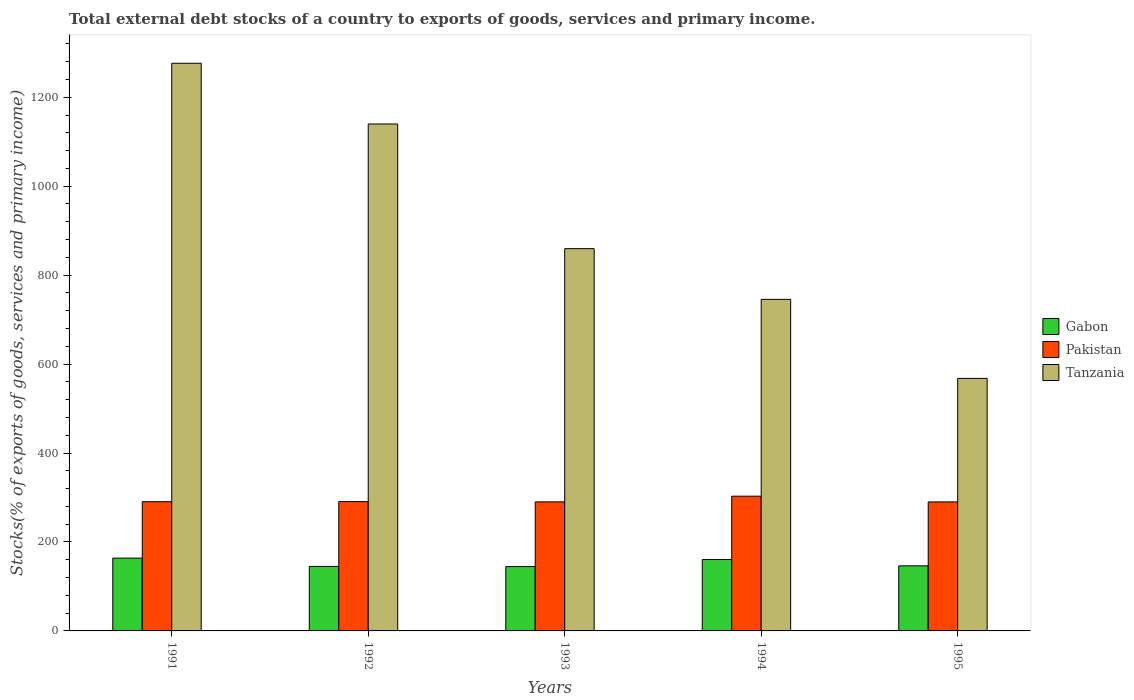How many different coloured bars are there?
Give a very brief answer. 3. Are the number of bars on each tick of the X-axis equal?
Offer a terse response. Yes. How many bars are there on the 4th tick from the left?
Offer a terse response. 3. What is the label of the 1st group of bars from the left?
Give a very brief answer. 1991. In how many cases, is the number of bars for a given year not equal to the number of legend labels?
Your answer should be very brief. 0. What is the total debt stocks in Pakistan in 1994?
Your response must be concise. 302.96. Across all years, what is the maximum total debt stocks in Gabon?
Your answer should be very brief. 163.68. Across all years, what is the minimum total debt stocks in Tanzania?
Keep it short and to the point. 567.82. In which year was the total debt stocks in Tanzania maximum?
Make the answer very short. 1991. What is the total total debt stocks in Pakistan in the graph?
Make the answer very short. 1464.63. What is the difference between the total debt stocks in Tanzania in 1992 and that in 1994?
Offer a very short reply. 394.38. What is the difference between the total debt stocks in Gabon in 1993 and the total debt stocks in Tanzania in 1991?
Keep it short and to the point. -1131.76. What is the average total debt stocks in Pakistan per year?
Offer a terse response. 292.93. In the year 1993, what is the difference between the total debt stocks in Tanzania and total debt stocks in Pakistan?
Give a very brief answer. 569.36. In how many years, is the total debt stocks in Gabon greater than 1280 %?
Ensure brevity in your answer.  0. What is the ratio of the total debt stocks in Gabon in 1991 to that in 1994?
Ensure brevity in your answer.  1.02. Is the difference between the total debt stocks in Tanzania in 1991 and 1994 greater than the difference between the total debt stocks in Pakistan in 1991 and 1994?
Keep it short and to the point. Yes. What is the difference between the highest and the second highest total debt stocks in Gabon?
Provide a succinct answer. 3.03. What is the difference between the highest and the lowest total debt stocks in Gabon?
Make the answer very short. 19.03. In how many years, is the total debt stocks in Pakistan greater than the average total debt stocks in Pakistan taken over all years?
Provide a short and direct response. 1. Is the sum of the total debt stocks in Gabon in 1993 and 1995 greater than the maximum total debt stocks in Pakistan across all years?
Keep it short and to the point. No. What does the 3rd bar from the left in 1994 represents?
Provide a succinct answer. Tanzania. Are all the bars in the graph horizontal?
Make the answer very short. No. Are the values on the major ticks of Y-axis written in scientific E-notation?
Keep it short and to the point. No. Where does the legend appear in the graph?
Offer a terse response. Center right. How are the legend labels stacked?
Keep it short and to the point. Vertical. What is the title of the graph?
Provide a short and direct response. Total external debt stocks of a country to exports of goods, services and primary income. Does "Uruguay" appear as one of the legend labels in the graph?
Keep it short and to the point. No. What is the label or title of the X-axis?
Make the answer very short. Years. What is the label or title of the Y-axis?
Offer a very short reply. Stocks(% of exports of goods, services and primary income). What is the Stocks(% of exports of goods, services and primary income) in Gabon in 1991?
Keep it short and to the point. 163.68. What is the Stocks(% of exports of goods, services and primary income) of Pakistan in 1991?
Provide a succinct answer. 290.61. What is the Stocks(% of exports of goods, services and primary income) in Tanzania in 1991?
Your answer should be very brief. 1276.41. What is the Stocks(% of exports of goods, services and primary income) of Gabon in 1992?
Make the answer very short. 145.06. What is the Stocks(% of exports of goods, services and primary income) of Pakistan in 1992?
Keep it short and to the point. 290.79. What is the Stocks(% of exports of goods, services and primary income) of Tanzania in 1992?
Offer a terse response. 1139.88. What is the Stocks(% of exports of goods, services and primary income) of Gabon in 1993?
Offer a terse response. 144.65. What is the Stocks(% of exports of goods, services and primary income) of Pakistan in 1993?
Give a very brief answer. 290.19. What is the Stocks(% of exports of goods, services and primary income) in Tanzania in 1993?
Ensure brevity in your answer.  859.54. What is the Stocks(% of exports of goods, services and primary income) of Gabon in 1994?
Provide a succinct answer. 160.65. What is the Stocks(% of exports of goods, services and primary income) of Pakistan in 1994?
Make the answer very short. 302.96. What is the Stocks(% of exports of goods, services and primary income) in Tanzania in 1994?
Offer a terse response. 745.5. What is the Stocks(% of exports of goods, services and primary income) of Gabon in 1995?
Your response must be concise. 146.34. What is the Stocks(% of exports of goods, services and primary income) in Pakistan in 1995?
Make the answer very short. 290.08. What is the Stocks(% of exports of goods, services and primary income) in Tanzania in 1995?
Offer a terse response. 567.82. Across all years, what is the maximum Stocks(% of exports of goods, services and primary income) of Gabon?
Offer a terse response. 163.68. Across all years, what is the maximum Stocks(% of exports of goods, services and primary income) in Pakistan?
Make the answer very short. 302.96. Across all years, what is the maximum Stocks(% of exports of goods, services and primary income) in Tanzania?
Offer a very short reply. 1276.41. Across all years, what is the minimum Stocks(% of exports of goods, services and primary income) in Gabon?
Your answer should be compact. 144.65. Across all years, what is the minimum Stocks(% of exports of goods, services and primary income) in Pakistan?
Offer a terse response. 290.08. Across all years, what is the minimum Stocks(% of exports of goods, services and primary income) of Tanzania?
Keep it short and to the point. 567.82. What is the total Stocks(% of exports of goods, services and primary income) in Gabon in the graph?
Ensure brevity in your answer.  760.38. What is the total Stocks(% of exports of goods, services and primary income) in Pakistan in the graph?
Give a very brief answer. 1464.63. What is the total Stocks(% of exports of goods, services and primary income) of Tanzania in the graph?
Provide a short and direct response. 4589.16. What is the difference between the Stocks(% of exports of goods, services and primary income) of Gabon in 1991 and that in 1992?
Offer a terse response. 18.62. What is the difference between the Stocks(% of exports of goods, services and primary income) of Pakistan in 1991 and that in 1992?
Offer a very short reply. -0.18. What is the difference between the Stocks(% of exports of goods, services and primary income) in Tanzania in 1991 and that in 1992?
Ensure brevity in your answer.  136.53. What is the difference between the Stocks(% of exports of goods, services and primary income) in Gabon in 1991 and that in 1993?
Give a very brief answer. 19.03. What is the difference between the Stocks(% of exports of goods, services and primary income) in Pakistan in 1991 and that in 1993?
Give a very brief answer. 0.43. What is the difference between the Stocks(% of exports of goods, services and primary income) in Tanzania in 1991 and that in 1993?
Give a very brief answer. 416.87. What is the difference between the Stocks(% of exports of goods, services and primary income) in Gabon in 1991 and that in 1994?
Provide a short and direct response. 3.03. What is the difference between the Stocks(% of exports of goods, services and primary income) of Pakistan in 1991 and that in 1994?
Offer a very short reply. -12.35. What is the difference between the Stocks(% of exports of goods, services and primary income) of Tanzania in 1991 and that in 1994?
Offer a very short reply. 530.91. What is the difference between the Stocks(% of exports of goods, services and primary income) of Gabon in 1991 and that in 1995?
Provide a short and direct response. 17.34. What is the difference between the Stocks(% of exports of goods, services and primary income) in Pakistan in 1991 and that in 1995?
Provide a short and direct response. 0.54. What is the difference between the Stocks(% of exports of goods, services and primary income) in Tanzania in 1991 and that in 1995?
Make the answer very short. 708.59. What is the difference between the Stocks(% of exports of goods, services and primary income) in Gabon in 1992 and that in 1993?
Your answer should be very brief. 0.41. What is the difference between the Stocks(% of exports of goods, services and primary income) of Pakistan in 1992 and that in 1993?
Give a very brief answer. 0.6. What is the difference between the Stocks(% of exports of goods, services and primary income) in Tanzania in 1992 and that in 1993?
Your answer should be compact. 280.34. What is the difference between the Stocks(% of exports of goods, services and primary income) of Gabon in 1992 and that in 1994?
Your answer should be very brief. -15.59. What is the difference between the Stocks(% of exports of goods, services and primary income) of Pakistan in 1992 and that in 1994?
Your response must be concise. -12.17. What is the difference between the Stocks(% of exports of goods, services and primary income) in Tanzania in 1992 and that in 1994?
Give a very brief answer. 394.38. What is the difference between the Stocks(% of exports of goods, services and primary income) in Gabon in 1992 and that in 1995?
Your response must be concise. -1.27. What is the difference between the Stocks(% of exports of goods, services and primary income) of Pakistan in 1992 and that in 1995?
Offer a very short reply. 0.72. What is the difference between the Stocks(% of exports of goods, services and primary income) in Tanzania in 1992 and that in 1995?
Your answer should be compact. 572.06. What is the difference between the Stocks(% of exports of goods, services and primary income) in Gabon in 1993 and that in 1994?
Make the answer very short. -16. What is the difference between the Stocks(% of exports of goods, services and primary income) in Pakistan in 1993 and that in 1994?
Your answer should be very brief. -12.77. What is the difference between the Stocks(% of exports of goods, services and primary income) of Tanzania in 1993 and that in 1994?
Your answer should be very brief. 114.04. What is the difference between the Stocks(% of exports of goods, services and primary income) of Gabon in 1993 and that in 1995?
Offer a terse response. -1.69. What is the difference between the Stocks(% of exports of goods, services and primary income) in Pakistan in 1993 and that in 1995?
Your response must be concise. 0.11. What is the difference between the Stocks(% of exports of goods, services and primary income) of Tanzania in 1993 and that in 1995?
Your answer should be very brief. 291.72. What is the difference between the Stocks(% of exports of goods, services and primary income) of Gabon in 1994 and that in 1995?
Your response must be concise. 14.31. What is the difference between the Stocks(% of exports of goods, services and primary income) of Pakistan in 1994 and that in 1995?
Provide a succinct answer. 12.89. What is the difference between the Stocks(% of exports of goods, services and primary income) of Tanzania in 1994 and that in 1995?
Your answer should be very brief. 177.68. What is the difference between the Stocks(% of exports of goods, services and primary income) in Gabon in 1991 and the Stocks(% of exports of goods, services and primary income) in Pakistan in 1992?
Keep it short and to the point. -127.11. What is the difference between the Stocks(% of exports of goods, services and primary income) in Gabon in 1991 and the Stocks(% of exports of goods, services and primary income) in Tanzania in 1992?
Your answer should be very brief. -976.2. What is the difference between the Stocks(% of exports of goods, services and primary income) in Pakistan in 1991 and the Stocks(% of exports of goods, services and primary income) in Tanzania in 1992?
Give a very brief answer. -849.27. What is the difference between the Stocks(% of exports of goods, services and primary income) of Gabon in 1991 and the Stocks(% of exports of goods, services and primary income) of Pakistan in 1993?
Make the answer very short. -126.51. What is the difference between the Stocks(% of exports of goods, services and primary income) in Gabon in 1991 and the Stocks(% of exports of goods, services and primary income) in Tanzania in 1993?
Provide a short and direct response. -695.86. What is the difference between the Stocks(% of exports of goods, services and primary income) of Pakistan in 1991 and the Stocks(% of exports of goods, services and primary income) of Tanzania in 1993?
Keep it short and to the point. -568.93. What is the difference between the Stocks(% of exports of goods, services and primary income) in Gabon in 1991 and the Stocks(% of exports of goods, services and primary income) in Pakistan in 1994?
Offer a very short reply. -139.28. What is the difference between the Stocks(% of exports of goods, services and primary income) of Gabon in 1991 and the Stocks(% of exports of goods, services and primary income) of Tanzania in 1994?
Provide a short and direct response. -581.82. What is the difference between the Stocks(% of exports of goods, services and primary income) of Pakistan in 1991 and the Stocks(% of exports of goods, services and primary income) of Tanzania in 1994?
Provide a short and direct response. -454.89. What is the difference between the Stocks(% of exports of goods, services and primary income) of Gabon in 1991 and the Stocks(% of exports of goods, services and primary income) of Pakistan in 1995?
Your answer should be compact. -126.4. What is the difference between the Stocks(% of exports of goods, services and primary income) of Gabon in 1991 and the Stocks(% of exports of goods, services and primary income) of Tanzania in 1995?
Provide a short and direct response. -404.14. What is the difference between the Stocks(% of exports of goods, services and primary income) in Pakistan in 1991 and the Stocks(% of exports of goods, services and primary income) in Tanzania in 1995?
Provide a succinct answer. -277.2. What is the difference between the Stocks(% of exports of goods, services and primary income) in Gabon in 1992 and the Stocks(% of exports of goods, services and primary income) in Pakistan in 1993?
Provide a short and direct response. -145.12. What is the difference between the Stocks(% of exports of goods, services and primary income) in Gabon in 1992 and the Stocks(% of exports of goods, services and primary income) in Tanzania in 1993?
Offer a terse response. -714.48. What is the difference between the Stocks(% of exports of goods, services and primary income) of Pakistan in 1992 and the Stocks(% of exports of goods, services and primary income) of Tanzania in 1993?
Keep it short and to the point. -568.75. What is the difference between the Stocks(% of exports of goods, services and primary income) in Gabon in 1992 and the Stocks(% of exports of goods, services and primary income) in Pakistan in 1994?
Your answer should be compact. -157.9. What is the difference between the Stocks(% of exports of goods, services and primary income) in Gabon in 1992 and the Stocks(% of exports of goods, services and primary income) in Tanzania in 1994?
Offer a terse response. -600.44. What is the difference between the Stocks(% of exports of goods, services and primary income) of Pakistan in 1992 and the Stocks(% of exports of goods, services and primary income) of Tanzania in 1994?
Offer a terse response. -454.71. What is the difference between the Stocks(% of exports of goods, services and primary income) of Gabon in 1992 and the Stocks(% of exports of goods, services and primary income) of Pakistan in 1995?
Provide a short and direct response. -145.01. What is the difference between the Stocks(% of exports of goods, services and primary income) of Gabon in 1992 and the Stocks(% of exports of goods, services and primary income) of Tanzania in 1995?
Make the answer very short. -422.76. What is the difference between the Stocks(% of exports of goods, services and primary income) in Pakistan in 1992 and the Stocks(% of exports of goods, services and primary income) in Tanzania in 1995?
Your answer should be compact. -277.03. What is the difference between the Stocks(% of exports of goods, services and primary income) in Gabon in 1993 and the Stocks(% of exports of goods, services and primary income) in Pakistan in 1994?
Your response must be concise. -158.31. What is the difference between the Stocks(% of exports of goods, services and primary income) of Gabon in 1993 and the Stocks(% of exports of goods, services and primary income) of Tanzania in 1994?
Give a very brief answer. -600.85. What is the difference between the Stocks(% of exports of goods, services and primary income) of Pakistan in 1993 and the Stocks(% of exports of goods, services and primary income) of Tanzania in 1994?
Keep it short and to the point. -455.32. What is the difference between the Stocks(% of exports of goods, services and primary income) of Gabon in 1993 and the Stocks(% of exports of goods, services and primary income) of Pakistan in 1995?
Give a very brief answer. -145.43. What is the difference between the Stocks(% of exports of goods, services and primary income) of Gabon in 1993 and the Stocks(% of exports of goods, services and primary income) of Tanzania in 1995?
Offer a terse response. -423.17. What is the difference between the Stocks(% of exports of goods, services and primary income) of Pakistan in 1993 and the Stocks(% of exports of goods, services and primary income) of Tanzania in 1995?
Offer a terse response. -277.63. What is the difference between the Stocks(% of exports of goods, services and primary income) in Gabon in 1994 and the Stocks(% of exports of goods, services and primary income) in Pakistan in 1995?
Keep it short and to the point. -129.43. What is the difference between the Stocks(% of exports of goods, services and primary income) in Gabon in 1994 and the Stocks(% of exports of goods, services and primary income) in Tanzania in 1995?
Provide a short and direct response. -407.17. What is the difference between the Stocks(% of exports of goods, services and primary income) of Pakistan in 1994 and the Stocks(% of exports of goods, services and primary income) of Tanzania in 1995?
Keep it short and to the point. -264.86. What is the average Stocks(% of exports of goods, services and primary income) in Gabon per year?
Keep it short and to the point. 152.08. What is the average Stocks(% of exports of goods, services and primary income) in Pakistan per year?
Your answer should be compact. 292.93. What is the average Stocks(% of exports of goods, services and primary income) in Tanzania per year?
Provide a succinct answer. 917.83. In the year 1991, what is the difference between the Stocks(% of exports of goods, services and primary income) in Gabon and Stocks(% of exports of goods, services and primary income) in Pakistan?
Your response must be concise. -126.93. In the year 1991, what is the difference between the Stocks(% of exports of goods, services and primary income) in Gabon and Stocks(% of exports of goods, services and primary income) in Tanzania?
Offer a very short reply. -1112.73. In the year 1991, what is the difference between the Stocks(% of exports of goods, services and primary income) in Pakistan and Stocks(% of exports of goods, services and primary income) in Tanzania?
Make the answer very short. -985.8. In the year 1992, what is the difference between the Stocks(% of exports of goods, services and primary income) in Gabon and Stocks(% of exports of goods, services and primary income) in Pakistan?
Keep it short and to the point. -145.73. In the year 1992, what is the difference between the Stocks(% of exports of goods, services and primary income) of Gabon and Stocks(% of exports of goods, services and primary income) of Tanzania?
Ensure brevity in your answer.  -994.82. In the year 1992, what is the difference between the Stocks(% of exports of goods, services and primary income) of Pakistan and Stocks(% of exports of goods, services and primary income) of Tanzania?
Your answer should be very brief. -849.09. In the year 1993, what is the difference between the Stocks(% of exports of goods, services and primary income) of Gabon and Stocks(% of exports of goods, services and primary income) of Pakistan?
Offer a very short reply. -145.54. In the year 1993, what is the difference between the Stocks(% of exports of goods, services and primary income) of Gabon and Stocks(% of exports of goods, services and primary income) of Tanzania?
Keep it short and to the point. -714.89. In the year 1993, what is the difference between the Stocks(% of exports of goods, services and primary income) in Pakistan and Stocks(% of exports of goods, services and primary income) in Tanzania?
Give a very brief answer. -569.36. In the year 1994, what is the difference between the Stocks(% of exports of goods, services and primary income) in Gabon and Stocks(% of exports of goods, services and primary income) in Pakistan?
Provide a short and direct response. -142.31. In the year 1994, what is the difference between the Stocks(% of exports of goods, services and primary income) of Gabon and Stocks(% of exports of goods, services and primary income) of Tanzania?
Offer a terse response. -584.85. In the year 1994, what is the difference between the Stocks(% of exports of goods, services and primary income) of Pakistan and Stocks(% of exports of goods, services and primary income) of Tanzania?
Provide a succinct answer. -442.54. In the year 1995, what is the difference between the Stocks(% of exports of goods, services and primary income) of Gabon and Stocks(% of exports of goods, services and primary income) of Pakistan?
Give a very brief answer. -143.74. In the year 1995, what is the difference between the Stocks(% of exports of goods, services and primary income) in Gabon and Stocks(% of exports of goods, services and primary income) in Tanzania?
Provide a short and direct response. -421.48. In the year 1995, what is the difference between the Stocks(% of exports of goods, services and primary income) in Pakistan and Stocks(% of exports of goods, services and primary income) in Tanzania?
Ensure brevity in your answer.  -277.74. What is the ratio of the Stocks(% of exports of goods, services and primary income) in Gabon in 1991 to that in 1992?
Your response must be concise. 1.13. What is the ratio of the Stocks(% of exports of goods, services and primary income) in Pakistan in 1991 to that in 1992?
Ensure brevity in your answer.  1. What is the ratio of the Stocks(% of exports of goods, services and primary income) in Tanzania in 1991 to that in 1992?
Your answer should be compact. 1.12. What is the ratio of the Stocks(% of exports of goods, services and primary income) in Gabon in 1991 to that in 1993?
Offer a very short reply. 1.13. What is the ratio of the Stocks(% of exports of goods, services and primary income) of Tanzania in 1991 to that in 1993?
Make the answer very short. 1.49. What is the ratio of the Stocks(% of exports of goods, services and primary income) of Gabon in 1991 to that in 1994?
Provide a succinct answer. 1.02. What is the ratio of the Stocks(% of exports of goods, services and primary income) of Pakistan in 1991 to that in 1994?
Keep it short and to the point. 0.96. What is the ratio of the Stocks(% of exports of goods, services and primary income) in Tanzania in 1991 to that in 1994?
Offer a very short reply. 1.71. What is the ratio of the Stocks(% of exports of goods, services and primary income) of Gabon in 1991 to that in 1995?
Offer a very short reply. 1.12. What is the ratio of the Stocks(% of exports of goods, services and primary income) in Tanzania in 1991 to that in 1995?
Your response must be concise. 2.25. What is the ratio of the Stocks(% of exports of goods, services and primary income) of Gabon in 1992 to that in 1993?
Ensure brevity in your answer.  1. What is the ratio of the Stocks(% of exports of goods, services and primary income) in Pakistan in 1992 to that in 1993?
Ensure brevity in your answer.  1. What is the ratio of the Stocks(% of exports of goods, services and primary income) of Tanzania in 1992 to that in 1993?
Offer a terse response. 1.33. What is the ratio of the Stocks(% of exports of goods, services and primary income) of Gabon in 1992 to that in 1994?
Your response must be concise. 0.9. What is the ratio of the Stocks(% of exports of goods, services and primary income) of Pakistan in 1992 to that in 1994?
Keep it short and to the point. 0.96. What is the ratio of the Stocks(% of exports of goods, services and primary income) of Tanzania in 1992 to that in 1994?
Offer a terse response. 1.53. What is the ratio of the Stocks(% of exports of goods, services and primary income) of Pakistan in 1992 to that in 1995?
Provide a short and direct response. 1. What is the ratio of the Stocks(% of exports of goods, services and primary income) of Tanzania in 1992 to that in 1995?
Make the answer very short. 2.01. What is the ratio of the Stocks(% of exports of goods, services and primary income) of Gabon in 1993 to that in 1994?
Ensure brevity in your answer.  0.9. What is the ratio of the Stocks(% of exports of goods, services and primary income) in Pakistan in 1993 to that in 1994?
Give a very brief answer. 0.96. What is the ratio of the Stocks(% of exports of goods, services and primary income) of Tanzania in 1993 to that in 1994?
Your response must be concise. 1.15. What is the ratio of the Stocks(% of exports of goods, services and primary income) in Gabon in 1993 to that in 1995?
Offer a very short reply. 0.99. What is the ratio of the Stocks(% of exports of goods, services and primary income) in Pakistan in 1993 to that in 1995?
Your answer should be very brief. 1. What is the ratio of the Stocks(% of exports of goods, services and primary income) in Tanzania in 1993 to that in 1995?
Your answer should be very brief. 1.51. What is the ratio of the Stocks(% of exports of goods, services and primary income) of Gabon in 1994 to that in 1995?
Provide a succinct answer. 1.1. What is the ratio of the Stocks(% of exports of goods, services and primary income) in Pakistan in 1994 to that in 1995?
Provide a succinct answer. 1.04. What is the ratio of the Stocks(% of exports of goods, services and primary income) in Tanzania in 1994 to that in 1995?
Offer a terse response. 1.31. What is the difference between the highest and the second highest Stocks(% of exports of goods, services and primary income) of Gabon?
Provide a succinct answer. 3.03. What is the difference between the highest and the second highest Stocks(% of exports of goods, services and primary income) in Pakistan?
Ensure brevity in your answer.  12.17. What is the difference between the highest and the second highest Stocks(% of exports of goods, services and primary income) of Tanzania?
Offer a terse response. 136.53. What is the difference between the highest and the lowest Stocks(% of exports of goods, services and primary income) in Gabon?
Make the answer very short. 19.03. What is the difference between the highest and the lowest Stocks(% of exports of goods, services and primary income) in Pakistan?
Provide a short and direct response. 12.89. What is the difference between the highest and the lowest Stocks(% of exports of goods, services and primary income) in Tanzania?
Your response must be concise. 708.59. 